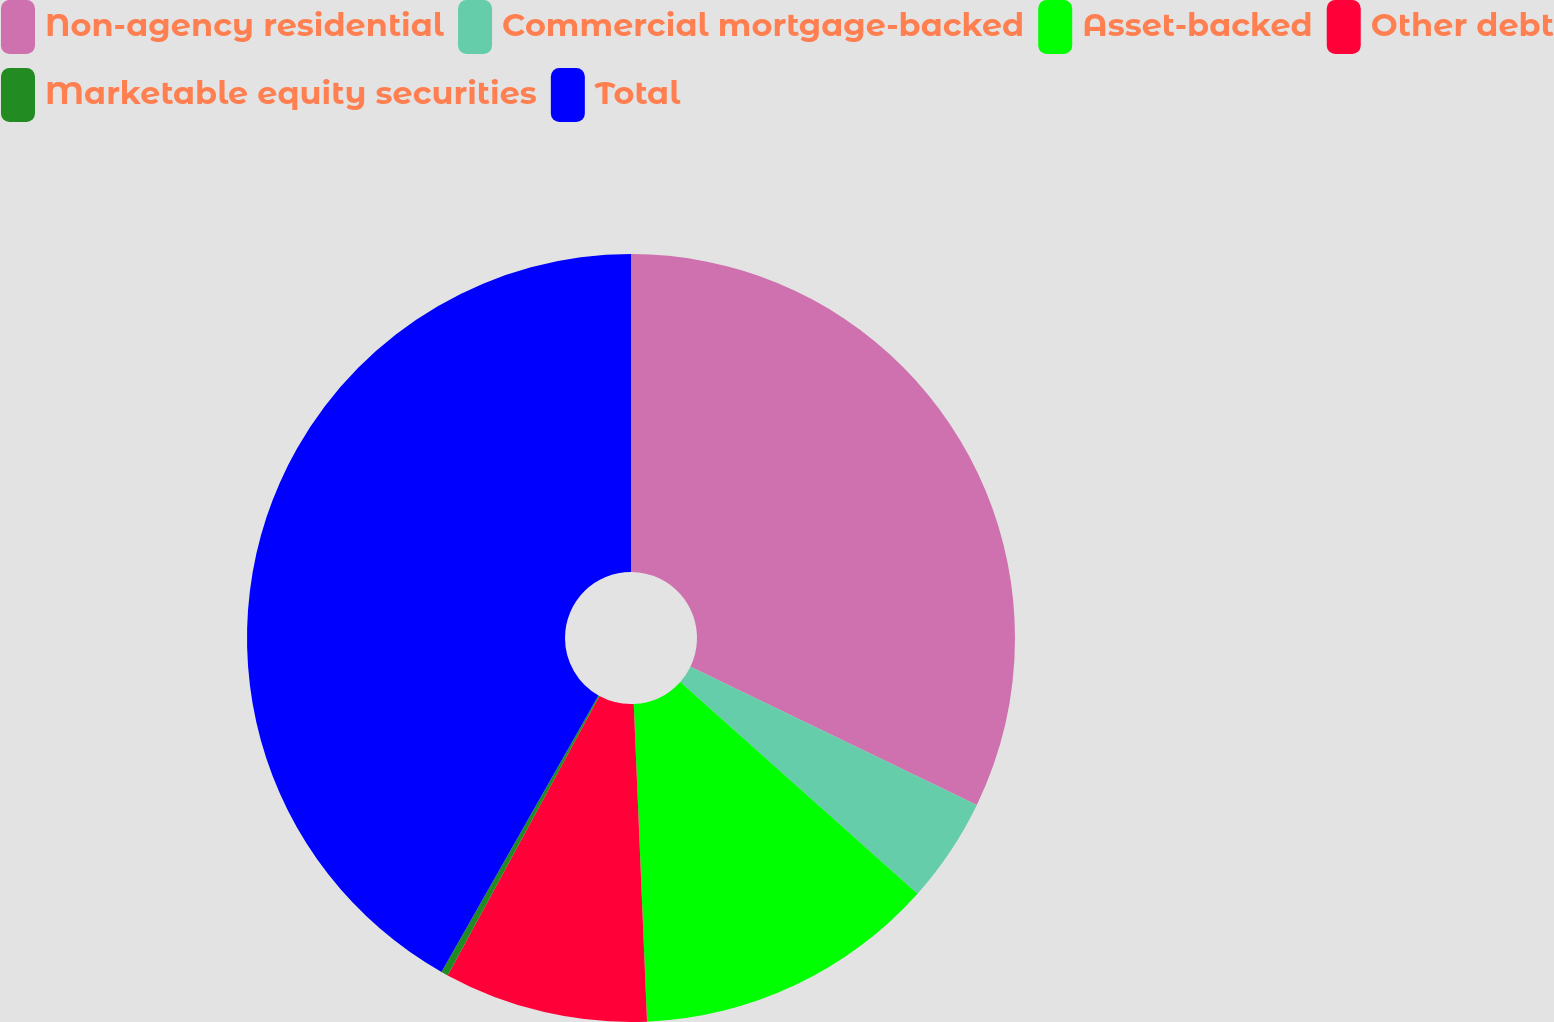Convert chart. <chart><loc_0><loc_0><loc_500><loc_500><pie_chart><fcel>Non-agency residential<fcel>Commercial mortgage-backed<fcel>Asset-backed<fcel>Other debt<fcel>Marketable equity securities<fcel>Total<nl><fcel>32.16%<fcel>4.44%<fcel>12.74%<fcel>8.59%<fcel>0.29%<fcel>41.79%<nl></chart> 